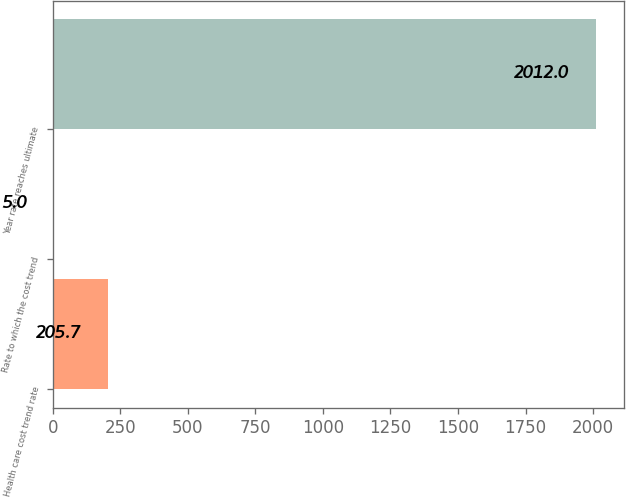<chart> <loc_0><loc_0><loc_500><loc_500><bar_chart><fcel>Health care cost trend rate<fcel>Rate to which the cost trend<fcel>Year rate reaches ultimate<nl><fcel>205.7<fcel>5<fcel>2012<nl></chart> 